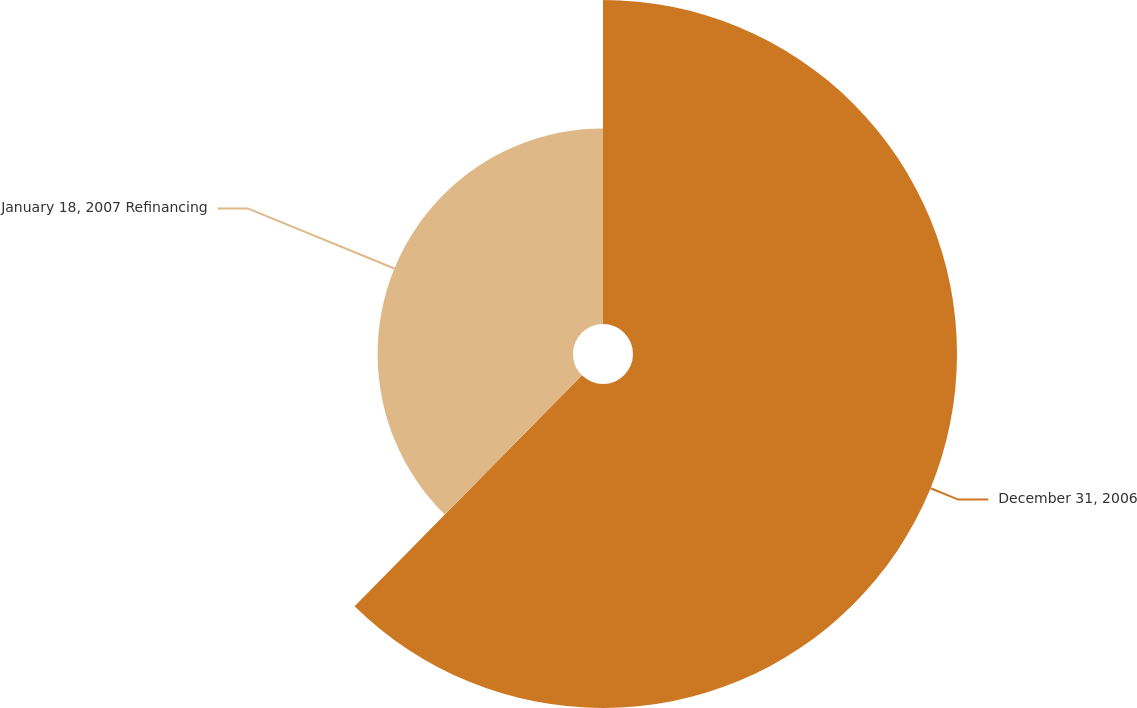Convert chart to OTSL. <chart><loc_0><loc_0><loc_500><loc_500><pie_chart><fcel>December 31, 2006<fcel>January 18, 2007 Refinancing<nl><fcel>62.38%<fcel>37.62%<nl></chart> 